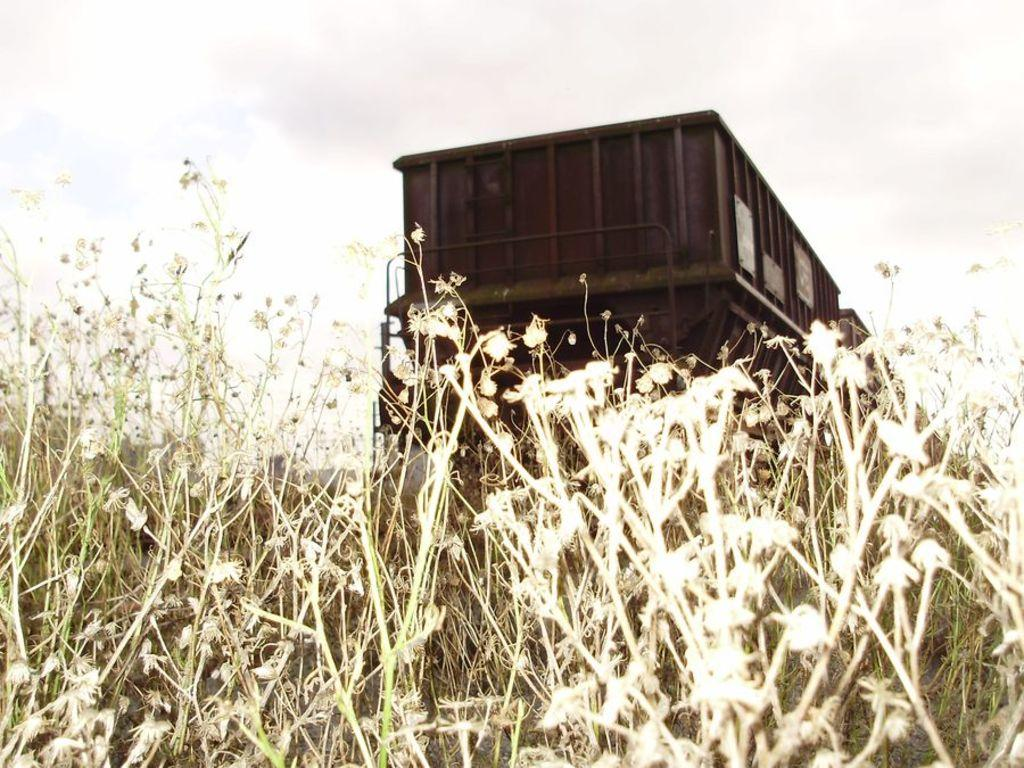What type of vehicle is present in the image? There is a goods wagon in the image. What type of vegetation can be seen in the image? There is grass visible in the image. What is the condition of the sky in the image? The sky is cloudy in the image. Is there a volcano erupting in the image? No, there is no volcano present in the image. How many times has the net been folded in the image? There is no net present in the image. 